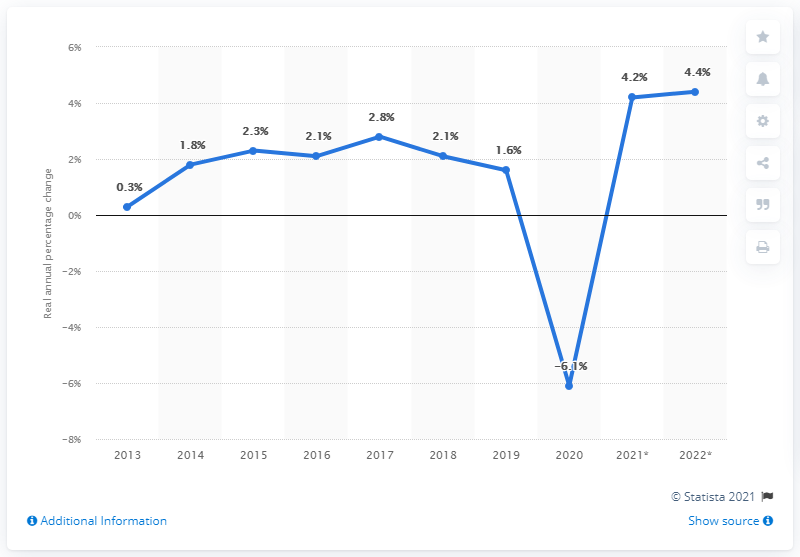Point out several critical features in this image. The growth rate forecast for 2021 is expected to be 4.2. 